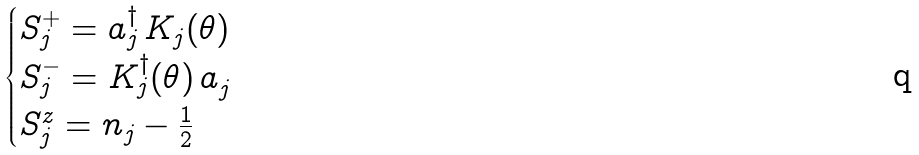Convert formula to latex. <formula><loc_0><loc_0><loc_500><loc_500>\begin{cases} S ^ { + } _ { j } = { a } ^ { \dagger } _ { j } \, K _ { j } ( \theta ) \\ S ^ { - } _ { j } = K _ { j } ^ { \dagger } ( \theta ) \, { a } ^ { \, } _ { j } \\ S ^ { z } _ { j } = n _ { j } - \frac { 1 } { 2 } \end{cases}</formula> 